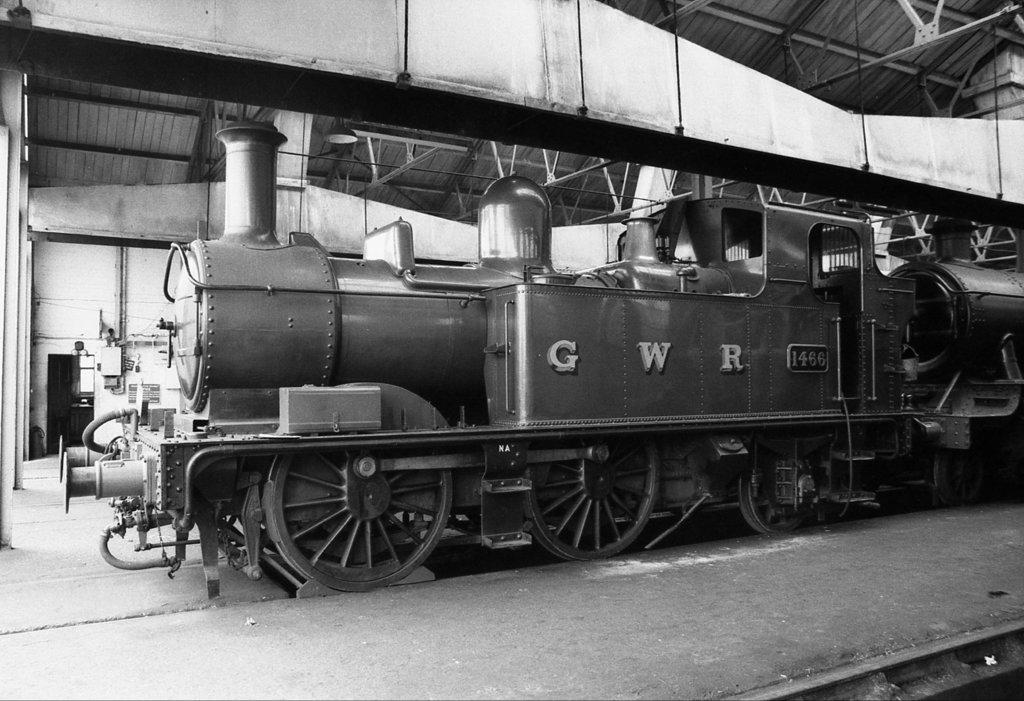What type of picture is in the image? The image contains a black and white picture. What is the main subject of the picture? The picture depicts a train on the ground. What can be seen above the picture in the image? There is a ceiling visible in the image. What can be seen to the side of the picture in the image? There is a wall visible in the image. What other objects can be seen in the image besides the picture? There are other objects visible in the image. What type of architectural feature is visible in the image? There is a door visible in the image. How many cherries are on the writer's desk in the image? There is no writer or desk present in the image, and therefore no cherries can be observed. 